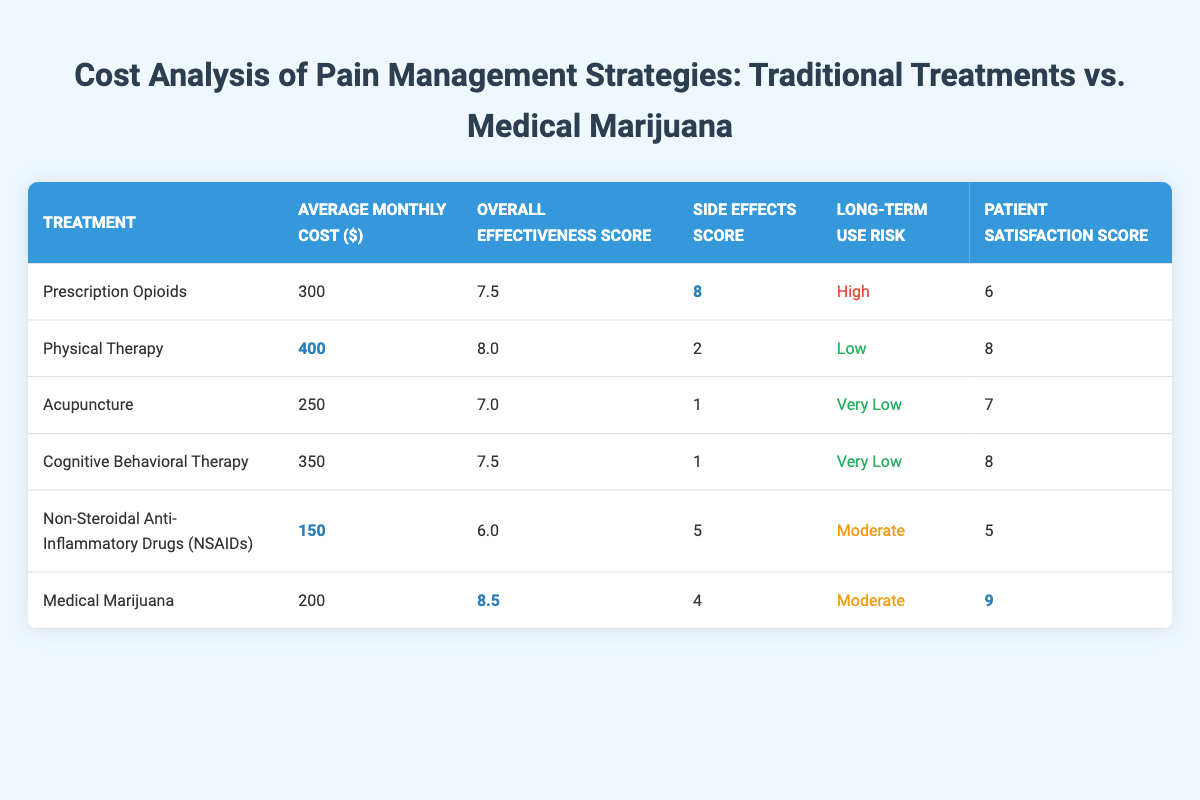What is the average monthly cost of Medical Marijuana? The table indicates that the average monthly cost for Medical Marijuana is listed as $200.
Answer: $200 Which treatment has the highest patient satisfaction score? According to the table, Medical Marijuana has the highest patient satisfaction score at 9.
Answer: Medical Marijuana What is the overall effectiveness score of Physical Therapy? The table shows that the overall effectiveness score for Physical Therapy is 8.0.
Answer: 8.0 True or False: Prescription Opioids have a lower average monthly cost than Physical Therapy. The average monthly cost of Prescription Opioids is $300, while Physical Therapy costs $400, indicating that Prescription Opioids are cheaper.
Answer: True What is the difference in average monthly cost between Non-Steroidal Anti-Inflammatory Drugs (NSAIDs) and Acupuncture? The average monthly cost of NSAIDs is $150 and Acupuncture is $250. The difference is $250 - $150 = $100.
Answer: $100 Which treatment has the lowest side effects score, and how does it compare to Medical Marijuana? The treatment with the lowest side effects score is Acupuncture, with a score of 1, while Medical Marijuana has a side effects score of 4. Therefore, Acupuncture's score is 3 points lower than Medical Marijuana.
Answer: Acupuncture; 3 points lower If a patient used Prescription Opioids and Medical Marijuana for a month, what would be the total cost? The average monthly cost for Prescription Opioids is $300 and for Medical Marijuana is $200. Summing these gives $300 + $200 = $500.
Answer: $500 Which treatment has the lowest long-term use risk? Acupuncture has the lowest long-term use risk, categorized as "Very Low" in the table.
Answer: Acupuncture What is the average effectiveness score of all listed treatments? The effectiveness scores are as follows: 7.5 (Opioids), 8.0 (Physical Therapy), 7.0 (Acupuncture), 7.5 (CBT), 6.0 (NSAIDs), and 8.5 (Medical Marijuana). Summing these scores gives 44.5, and there are 6 treatments, so the average is 44.5 / 6 = 7.42.
Answer: 7.42 Which treatment option has both low cost and high effectiveness score? Non-Steroidal Anti-Inflammatory Drugs (NSAIDs) have the lowest cost at $150 and an effectiveness score of 6.0, while Acupuncture offers a decent effectiveness score of 7.0 at $250. Though neither is ideal, the lowest cost with reasonable effectiveness is NSAIDs.
Answer: NSAIDs 